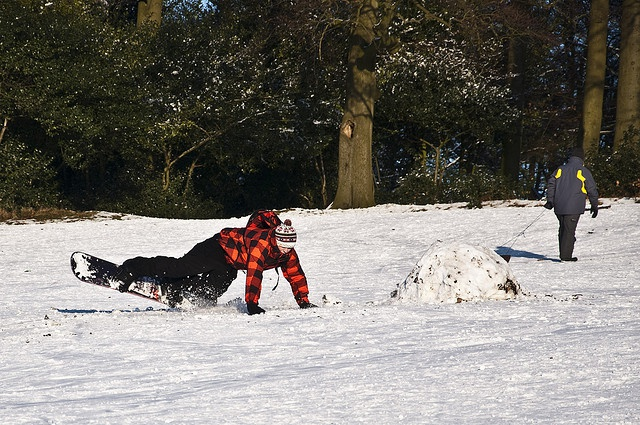Describe the objects in this image and their specific colors. I can see people in black, maroon, brown, and white tones, people in black and gray tones, and snowboard in black, white, gray, and darkgray tones in this image. 